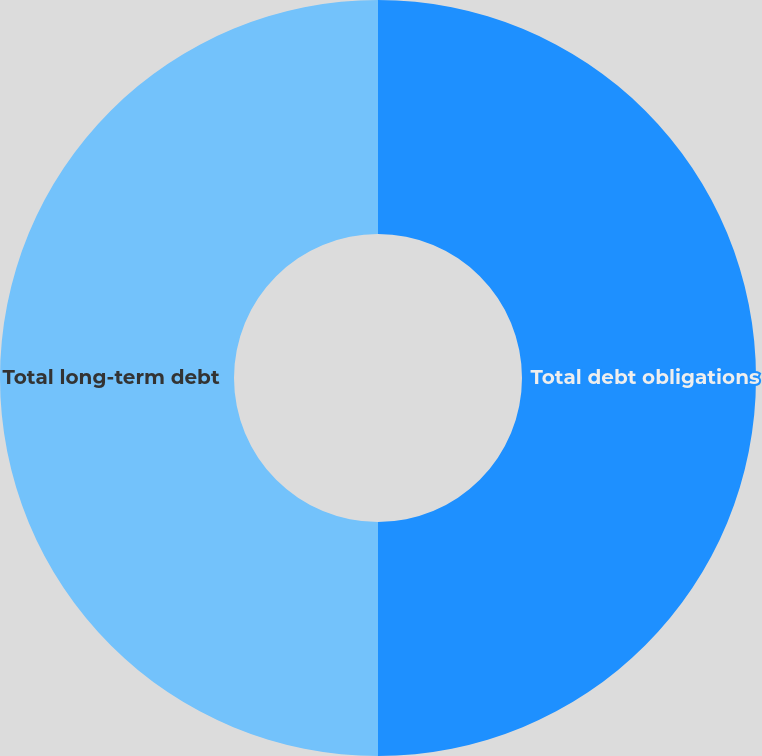Convert chart. <chart><loc_0><loc_0><loc_500><loc_500><pie_chart><fcel>Total debt obligations<fcel>Total long-term debt<nl><fcel>50.0%<fcel>50.0%<nl></chart> 